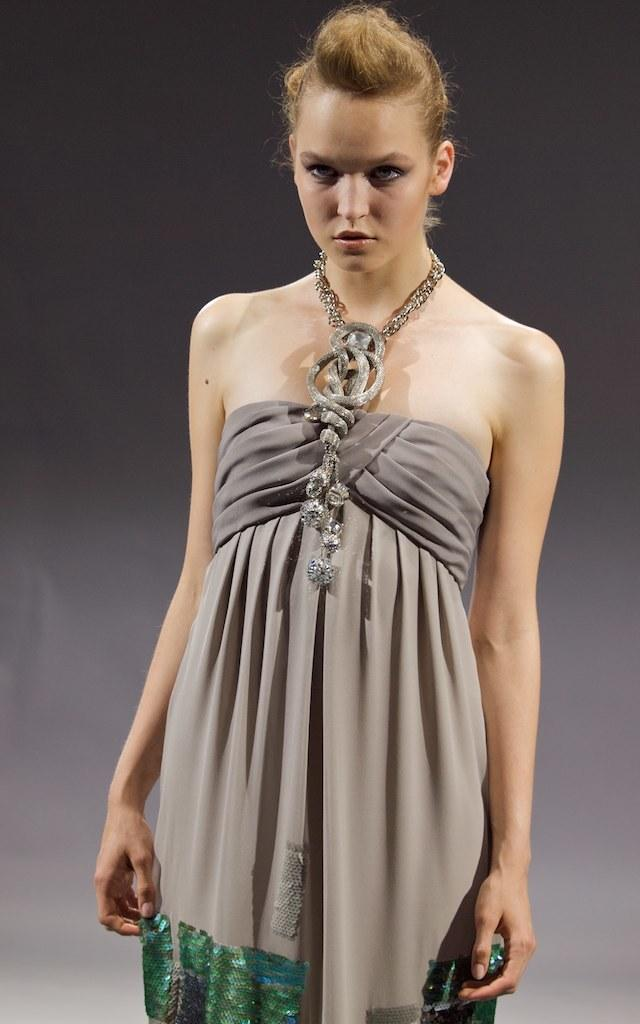What is the main subject of the image? There is a person in the image. Can you describe the person's attire? The person is wearing clothes. What is the color of the background in the image? The background of the image is dark. What type of lead can be seen in the image? There is no lead present in the image. How many lines can be seen in the image? There is no specific mention of lines in the image; it features a person in a dark background. 